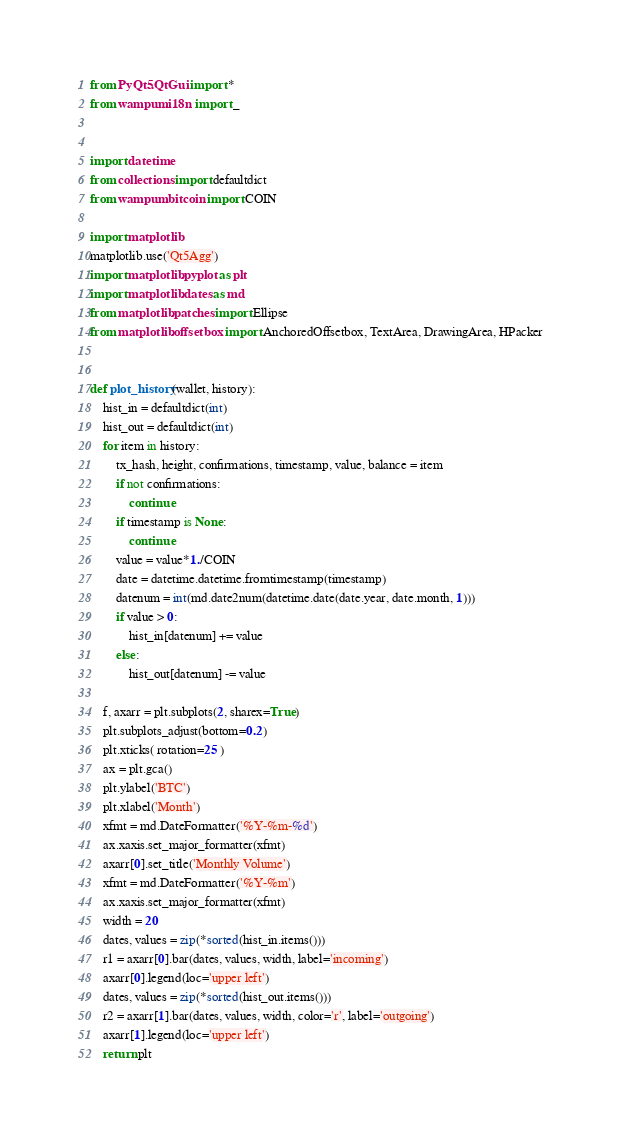Convert code to text. <code><loc_0><loc_0><loc_500><loc_500><_Python_>from PyQt5.QtGui import *
from wampum.i18n import _


import datetime
from collections import defaultdict
from wampum.bitcoin import COIN

import matplotlib
matplotlib.use('Qt5Agg')
import matplotlib.pyplot as plt
import matplotlib.dates as md
from matplotlib.patches import Ellipse
from matplotlib.offsetbox import AnchoredOffsetbox, TextArea, DrawingArea, HPacker


def plot_history(wallet, history):
    hist_in = defaultdict(int)
    hist_out = defaultdict(int)
    for item in history:
        tx_hash, height, confirmations, timestamp, value, balance = item
        if not confirmations:
            continue
        if timestamp is None:
            continue
        value = value*1./COIN
        date = datetime.datetime.fromtimestamp(timestamp)
        datenum = int(md.date2num(datetime.date(date.year, date.month, 1)))
        if value > 0:
            hist_in[datenum] += value
        else:
            hist_out[datenum] -= value

    f, axarr = plt.subplots(2, sharex=True)
    plt.subplots_adjust(bottom=0.2)
    plt.xticks( rotation=25 )
    ax = plt.gca()
    plt.ylabel('BTC')
    plt.xlabel('Month')
    xfmt = md.DateFormatter('%Y-%m-%d')
    ax.xaxis.set_major_formatter(xfmt)
    axarr[0].set_title('Monthly Volume')
    xfmt = md.DateFormatter('%Y-%m')
    ax.xaxis.set_major_formatter(xfmt)
    width = 20
    dates, values = zip(*sorted(hist_in.items()))
    r1 = axarr[0].bar(dates, values, width, label='incoming')
    axarr[0].legend(loc='upper left')
    dates, values = zip(*sorted(hist_out.items()))
    r2 = axarr[1].bar(dates, values, width, color='r', label='outgoing')
    axarr[1].legend(loc='upper left')
    return plt
</code> 